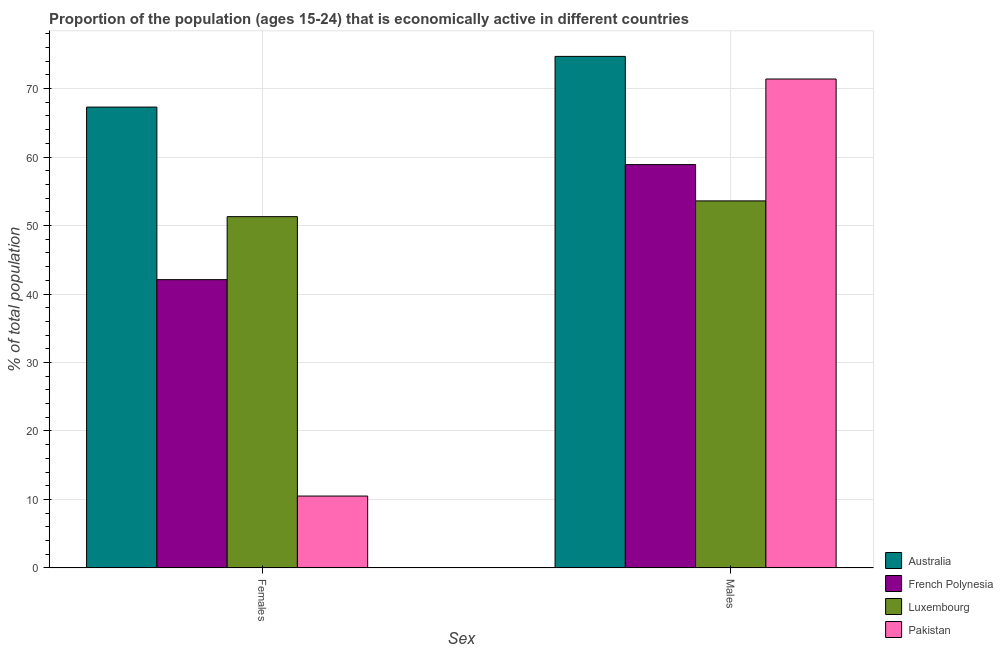How many different coloured bars are there?
Offer a terse response. 4. How many groups of bars are there?
Provide a short and direct response. 2. Are the number of bars on each tick of the X-axis equal?
Your answer should be compact. Yes. How many bars are there on the 1st tick from the right?
Your answer should be very brief. 4. What is the label of the 2nd group of bars from the left?
Your answer should be very brief. Males. What is the percentage of economically active male population in Australia?
Provide a short and direct response. 74.7. Across all countries, what is the maximum percentage of economically active male population?
Your response must be concise. 74.7. Across all countries, what is the minimum percentage of economically active male population?
Your answer should be compact. 53.6. In which country was the percentage of economically active female population maximum?
Offer a very short reply. Australia. In which country was the percentage of economically active female population minimum?
Offer a very short reply. Pakistan. What is the total percentage of economically active male population in the graph?
Your answer should be very brief. 258.6. What is the difference between the percentage of economically active female population in French Polynesia and that in Pakistan?
Give a very brief answer. 31.6. What is the difference between the percentage of economically active male population in Australia and the percentage of economically active female population in Luxembourg?
Keep it short and to the point. 23.4. What is the average percentage of economically active male population per country?
Give a very brief answer. 64.65. What is the difference between the percentage of economically active male population and percentage of economically active female population in French Polynesia?
Provide a short and direct response. 16.8. What is the ratio of the percentage of economically active male population in French Polynesia to that in Pakistan?
Keep it short and to the point. 0.82. Is the percentage of economically active male population in Pakistan less than that in French Polynesia?
Make the answer very short. No. In how many countries, is the percentage of economically active male population greater than the average percentage of economically active male population taken over all countries?
Your answer should be very brief. 2. What does the 3rd bar from the right in Males represents?
Provide a succinct answer. French Polynesia. How many countries are there in the graph?
Make the answer very short. 4. Are the values on the major ticks of Y-axis written in scientific E-notation?
Give a very brief answer. No. Does the graph contain any zero values?
Offer a very short reply. No. Does the graph contain grids?
Provide a short and direct response. Yes. How many legend labels are there?
Offer a very short reply. 4. What is the title of the graph?
Provide a succinct answer. Proportion of the population (ages 15-24) that is economically active in different countries. Does "Bhutan" appear as one of the legend labels in the graph?
Your response must be concise. No. What is the label or title of the X-axis?
Offer a very short reply. Sex. What is the label or title of the Y-axis?
Your response must be concise. % of total population. What is the % of total population of Australia in Females?
Your answer should be compact. 67.3. What is the % of total population of French Polynesia in Females?
Offer a terse response. 42.1. What is the % of total population in Luxembourg in Females?
Make the answer very short. 51.3. What is the % of total population in Pakistan in Females?
Provide a short and direct response. 10.5. What is the % of total population of Australia in Males?
Make the answer very short. 74.7. What is the % of total population of French Polynesia in Males?
Ensure brevity in your answer.  58.9. What is the % of total population in Luxembourg in Males?
Keep it short and to the point. 53.6. What is the % of total population of Pakistan in Males?
Give a very brief answer. 71.4. Across all Sex, what is the maximum % of total population in Australia?
Make the answer very short. 74.7. Across all Sex, what is the maximum % of total population in French Polynesia?
Provide a short and direct response. 58.9. Across all Sex, what is the maximum % of total population of Luxembourg?
Offer a terse response. 53.6. Across all Sex, what is the maximum % of total population in Pakistan?
Offer a terse response. 71.4. Across all Sex, what is the minimum % of total population in Australia?
Your answer should be compact. 67.3. Across all Sex, what is the minimum % of total population in French Polynesia?
Offer a terse response. 42.1. Across all Sex, what is the minimum % of total population of Luxembourg?
Keep it short and to the point. 51.3. What is the total % of total population of Australia in the graph?
Make the answer very short. 142. What is the total % of total population of French Polynesia in the graph?
Make the answer very short. 101. What is the total % of total population of Luxembourg in the graph?
Your answer should be compact. 104.9. What is the total % of total population in Pakistan in the graph?
Ensure brevity in your answer.  81.9. What is the difference between the % of total population of French Polynesia in Females and that in Males?
Offer a very short reply. -16.8. What is the difference between the % of total population of Pakistan in Females and that in Males?
Your answer should be compact. -60.9. What is the difference between the % of total population in Australia in Females and the % of total population in Pakistan in Males?
Your response must be concise. -4.1. What is the difference between the % of total population in French Polynesia in Females and the % of total population in Luxembourg in Males?
Provide a short and direct response. -11.5. What is the difference between the % of total population in French Polynesia in Females and the % of total population in Pakistan in Males?
Offer a very short reply. -29.3. What is the difference between the % of total population in Luxembourg in Females and the % of total population in Pakistan in Males?
Your response must be concise. -20.1. What is the average % of total population of Australia per Sex?
Provide a succinct answer. 71. What is the average % of total population in French Polynesia per Sex?
Provide a succinct answer. 50.5. What is the average % of total population in Luxembourg per Sex?
Your response must be concise. 52.45. What is the average % of total population of Pakistan per Sex?
Your answer should be very brief. 40.95. What is the difference between the % of total population in Australia and % of total population in French Polynesia in Females?
Keep it short and to the point. 25.2. What is the difference between the % of total population in Australia and % of total population in Luxembourg in Females?
Your response must be concise. 16. What is the difference between the % of total population in Australia and % of total population in Pakistan in Females?
Provide a succinct answer. 56.8. What is the difference between the % of total population in French Polynesia and % of total population in Pakistan in Females?
Offer a very short reply. 31.6. What is the difference between the % of total population of Luxembourg and % of total population of Pakistan in Females?
Provide a short and direct response. 40.8. What is the difference between the % of total population of Australia and % of total population of Luxembourg in Males?
Ensure brevity in your answer.  21.1. What is the difference between the % of total population in Australia and % of total population in Pakistan in Males?
Your answer should be very brief. 3.3. What is the difference between the % of total population of Luxembourg and % of total population of Pakistan in Males?
Your response must be concise. -17.8. What is the ratio of the % of total population in Australia in Females to that in Males?
Ensure brevity in your answer.  0.9. What is the ratio of the % of total population in French Polynesia in Females to that in Males?
Keep it short and to the point. 0.71. What is the ratio of the % of total population of Luxembourg in Females to that in Males?
Your answer should be compact. 0.96. What is the ratio of the % of total population of Pakistan in Females to that in Males?
Give a very brief answer. 0.15. What is the difference between the highest and the second highest % of total population of Australia?
Offer a terse response. 7.4. What is the difference between the highest and the second highest % of total population in Pakistan?
Make the answer very short. 60.9. What is the difference between the highest and the lowest % of total population of French Polynesia?
Keep it short and to the point. 16.8. What is the difference between the highest and the lowest % of total population in Pakistan?
Keep it short and to the point. 60.9. 